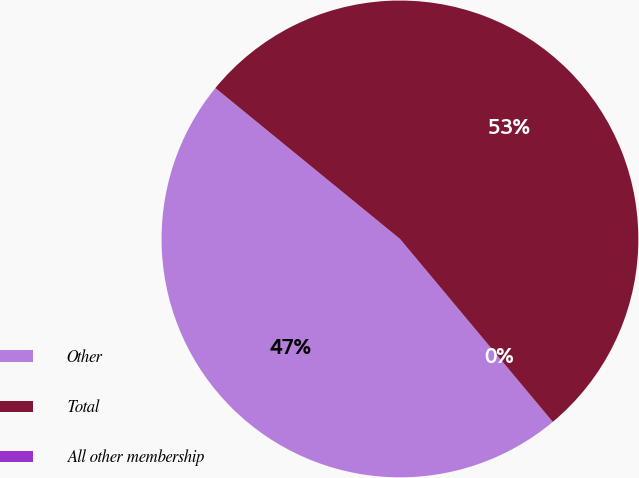Convert chart to OTSL. <chart><loc_0><loc_0><loc_500><loc_500><pie_chart><fcel>Other<fcel>Total<fcel>All other membership<nl><fcel>46.98%<fcel>53.02%<fcel>0.0%<nl></chart> 